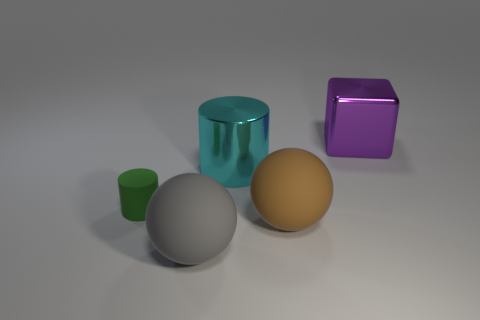Is the shape of the big brown thing the same as the big matte thing to the left of the big cylinder?
Offer a very short reply. Yes. Are there more big cyan things than cylinders?
Offer a very short reply. No. Are there any other things that are the same size as the green object?
Your answer should be compact. No. There is a large metallic object in front of the purple shiny cube; does it have the same shape as the tiny green rubber object?
Make the answer very short. Yes. Are there more metal blocks behind the large brown rubber object than small cyan rubber objects?
Provide a short and direct response. Yes. The large rubber thing that is behind the big matte sphere that is left of the metallic cylinder is what color?
Give a very brief answer. Brown. What number of big red cubes are there?
Ensure brevity in your answer.  0. What number of things are both on the right side of the small cylinder and in front of the big purple cube?
Offer a very short reply. 3. Is there anything else that has the same shape as the large purple shiny object?
Provide a succinct answer. No. The metal thing left of the big shiny block has what shape?
Offer a terse response. Cylinder. 